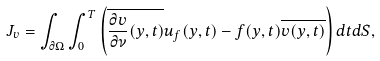<formula> <loc_0><loc_0><loc_500><loc_500>J _ { v } = \int _ { \partial \Omega } \int _ { 0 } ^ { T } \left ( \overline { \frac { \partial v } { \partial \nu } ( y , t ) } u _ { f } ( y , t ) - f ( y , t ) \overline { v ( y , t ) } \right ) d t d S ,</formula> 